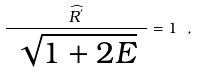Convert formula to latex. <formula><loc_0><loc_0><loc_500><loc_500>\frac { \widehat { R ^ { ^ { \prime } } } } { \ \sqrt { 1 + 2 E } \ } = 1 \ ,</formula> 